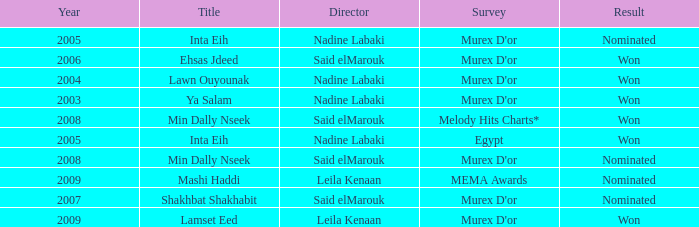What is the title for the Murex D'or survey, after 2005, Said Elmarouk as director, and was nominated? Shakhbat Shakhabit, Min Dally Nseek. 